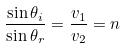<formula> <loc_0><loc_0><loc_500><loc_500>\frac { \sin \theta _ { i } } { \sin \theta _ { r } } = \frac { v _ { 1 } } { v _ { 2 } } = n</formula> 